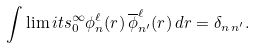Convert formula to latex. <formula><loc_0><loc_0><loc_500><loc_500>\int \lim i t s _ { 0 } ^ { \infty } \phi _ { n } ^ { \ell } ( r ) \, \overline { \phi } _ { n ^ { \prime } } ^ { \ell } ( r ) \, d r = \delta _ { n \, n ^ { \prime } } .</formula> 